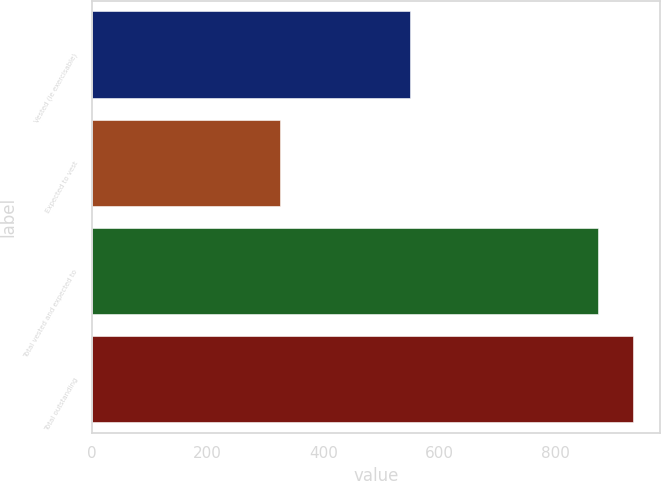Convert chart. <chart><loc_0><loc_0><loc_500><loc_500><bar_chart><fcel>Vested (ie exercisable)<fcel>Expected to vest<fcel>Total vested and expected to<fcel>Total outstanding<nl><fcel>549<fcel>325<fcel>874<fcel>934<nl></chart> 